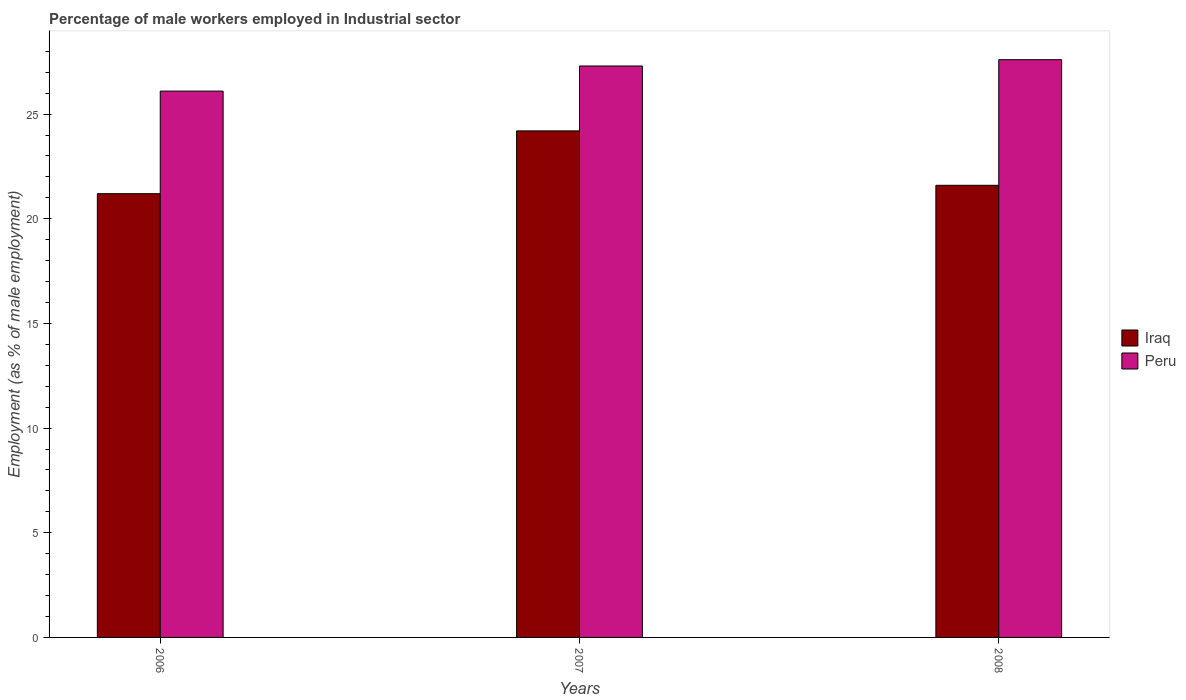How many groups of bars are there?
Your answer should be compact. 3. Are the number of bars per tick equal to the number of legend labels?
Give a very brief answer. Yes. Are the number of bars on each tick of the X-axis equal?
Provide a short and direct response. Yes. How many bars are there on the 1st tick from the left?
Your response must be concise. 2. How many bars are there on the 3rd tick from the right?
Provide a succinct answer. 2. In how many cases, is the number of bars for a given year not equal to the number of legend labels?
Offer a very short reply. 0. What is the percentage of male workers employed in Industrial sector in Iraq in 2007?
Make the answer very short. 24.2. Across all years, what is the maximum percentage of male workers employed in Industrial sector in Iraq?
Offer a terse response. 24.2. Across all years, what is the minimum percentage of male workers employed in Industrial sector in Peru?
Offer a terse response. 26.1. In which year was the percentage of male workers employed in Industrial sector in Peru maximum?
Provide a short and direct response. 2008. In which year was the percentage of male workers employed in Industrial sector in Iraq minimum?
Provide a succinct answer. 2006. What is the total percentage of male workers employed in Industrial sector in Iraq in the graph?
Your answer should be compact. 67. What is the difference between the percentage of male workers employed in Industrial sector in Iraq in 2006 and that in 2008?
Make the answer very short. -0.4. What is the difference between the percentage of male workers employed in Industrial sector in Peru in 2008 and the percentage of male workers employed in Industrial sector in Iraq in 2006?
Provide a short and direct response. 6.4. What is the average percentage of male workers employed in Industrial sector in Iraq per year?
Provide a short and direct response. 22.33. In the year 2008, what is the difference between the percentage of male workers employed in Industrial sector in Peru and percentage of male workers employed in Industrial sector in Iraq?
Keep it short and to the point. 6. In how many years, is the percentage of male workers employed in Industrial sector in Peru greater than 3 %?
Your response must be concise. 3. What is the ratio of the percentage of male workers employed in Industrial sector in Iraq in 2006 to that in 2008?
Your answer should be compact. 0.98. What is the difference between the highest and the second highest percentage of male workers employed in Industrial sector in Iraq?
Give a very brief answer. 2.6. What is the difference between the highest and the lowest percentage of male workers employed in Industrial sector in Iraq?
Your answer should be very brief. 3. In how many years, is the percentage of male workers employed in Industrial sector in Peru greater than the average percentage of male workers employed in Industrial sector in Peru taken over all years?
Your response must be concise. 2. Is the sum of the percentage of male workers employed in Industrial sector in Peru in 2006 and 2007 greater than the maximum percentage of male workers employed in Industrial sector in Iraq across all years?
Keep it short and to the point. Yes. How many bars are there?
Give a very brief answer. 6. How many years are there in the graph?
Make the answer very short. 3. Are the values on the major ticks of Y-axis written in scientific E-notation?
Your response must be concise. No. Does the graph contain grids?
Keep it short and to the point. No. How many legend labels are there?
Ensure brevity in your answer.  2. How are the legend labels stacked?
Provide a succinct answer. Vertical. What is the title of the graph?
Give a very brief answer. Percentage of male workers employed in Industrial sector. Does "Sudan" appear as one of the legend labels in the graph?
Offer a terse response. No. What is the label or title of the X-axis?
Your answer should be compact. Years. What is the label or title of the Y-axis?
Your answer should be compact. Employment (as % of male employment). What is the Employment (as % of male employment) in Iraq in 2006?
Your answer should be very brief. 21.2. What is the Employment (as % of male employment) in Peru in 2006?
Your answer should be compact. 26.1. What is the Employment (as % of male employment) of Iraq in 2007?
Offer a terse response. 24.2. What is the Employment (as % of male employment) in Peru in 2007?
Your answer should be very brief. 27.3. What is the Employment (as % of male employment) in Iraq in 2008?
Your answer should be very brief. 21.6. What is the Employment (as % of male employment) in Peru in 2008?
Ensure brevity in your answer.  27.6. Across all years, what is the maximum Employment (as % of male employment) in Iraq?
Provide a succinct answer. 24.2. Across all years, what is the maximum Employment (as % of male employment) of Peru?
Provide a succinct answer. 27.6. Across all years, what is the minimum Employment (as % of male employment) in Iraq?
Provide a short and direct response. 21.2. Across all years, what is the minimum Employment (as % of male employment) of Peru?
Your answer should be compact. 26.1. What is the total Employment (as % of male employment) of Iraq in the graph?
Your answer should be compact. 67. What is the total Employment (as % of male employment) in Peru in the graph?
Provide a succinct answer. 81. What is the difference between the Employment (as % of male employment) of Iraq in 2006 and that in 2007?
Your answer should be compact. -3. What is the difference between the Employment (as % of male employment) in Peru in 2006 and that in 2007?
Your answer should be very brief. -1.2. What is the difference between the Employment (as % of male employment) of Peru in 2006 and that in 2008?
Your answer should be very brief. -1.5. What is the difference between the Employment (as % of male employment) of Iraq in 2006 and the Employment (as % of male employment) of Peru in 2008?
Your answer should be very brief. -6.4. What is the average Employment (as % of male employment) in Iraq per year?
Provide a succinct answer. 22.33. In the year 2008, what is the difference between the Employment (as % of male employment) in Iraq and Employment (as % of male employment) in Peru?
Ensure brevity in your answer.  -6. What is the ratio of the Employment (as % of male employment) of Iraq in 2006 to that in 2007?
Ensure brevity in your answer.  0.88. What is the ratio of the Employment (as % of male employment) of Peru in 2006 to that in 2007?
Offer a terse response. 0.96. What is the ratio of the Employment (as % of male employment) in Iraq in 2006 to that in 2008?
Your answer should be compact. 0.98. What is the ratio of the Employment (as % of male employment) in Peru in 2006 to that in 2008?
Make the answer very short. 0.95. What is the ratio of the Employment (as % of male employment) of Iraq in 2007 to that in 2008?
Provide a succinct answer. 1.12. What is the difference between the highest and the lowest Employment (as % of male employment) of Iraq?
Ensure brevity in your answer.  3. What is the difference between the highest and the lowest Employment (as % of male employment) in Peru?
Provide a short and direct response. 1.5. 